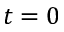Convert formula to latex. <formula><loc_0><loc_0><loc_500><loc_500>t = 0</formula> 